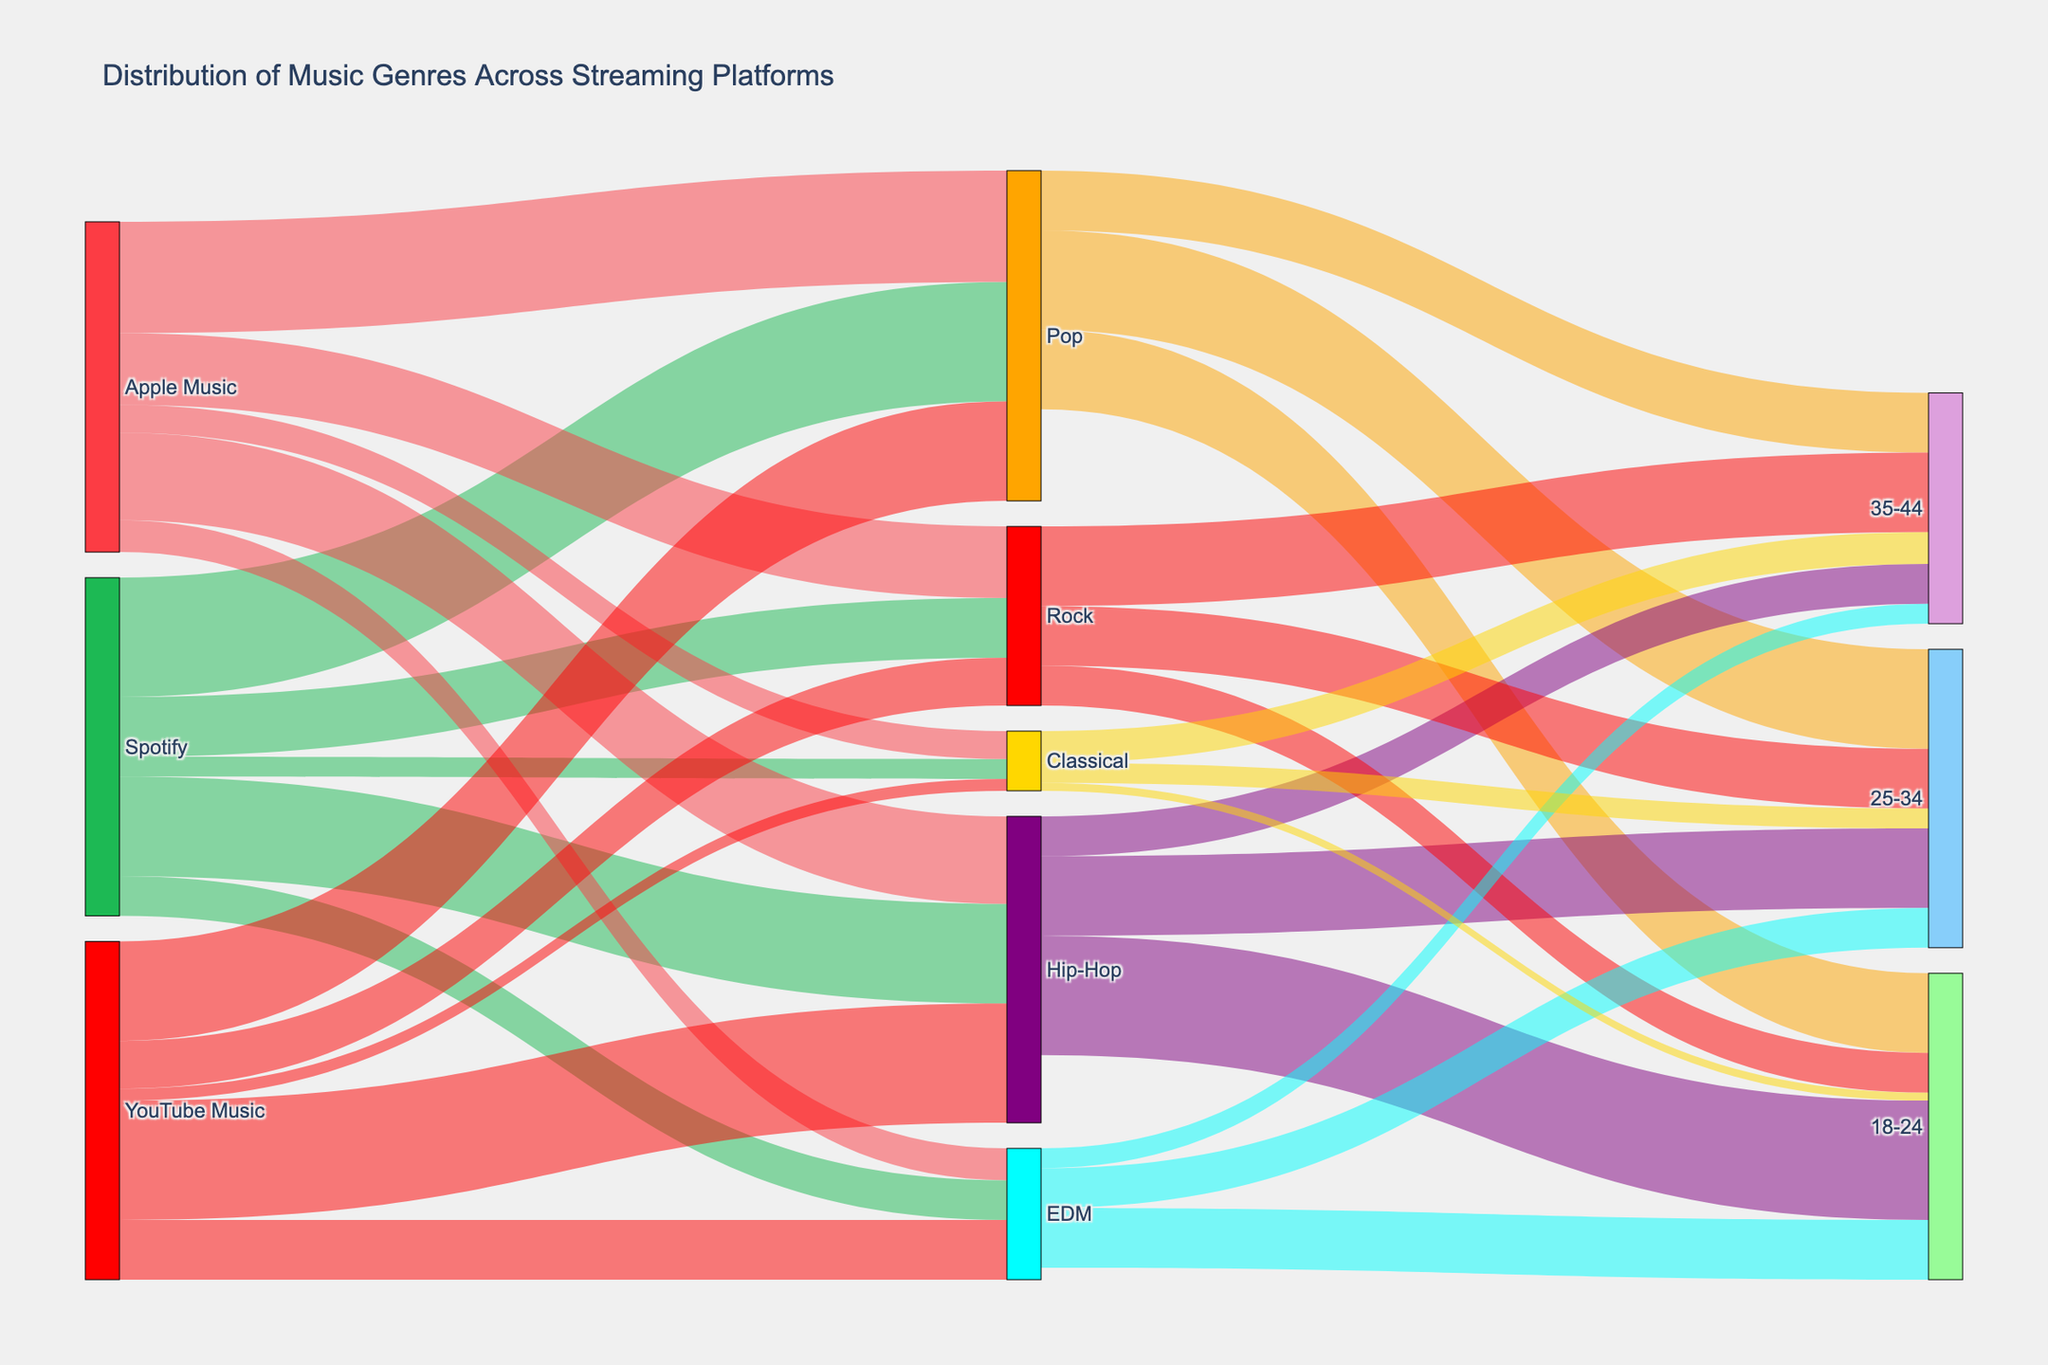What is the most popular music genre on Spotify? According to the Sankey diagram, the highest value link connected to Spotify is directed towards Pop, with a value of 30, making it the most popular genre on the platform.
Answer: Pop Which age group prefers Classical music the least? Based on the links directed towards Classical music, the 18-24 age group has the smallest value of 2, indicating they prefer it the least.
Answer: 18-24 Which platform has the highest proportion of Hip-Hop listeners? The highest value linked to Hip-Hop is from YouTube Music, with a value of 30, compared to values of 25 and 22 for Spotify and Apple Music, respectively.
Answer: YouTube Music How much more popular is Rock on Apple Music than on Spotify? The values linked to Rock are 18 for Apple Music and 15 for Spotify. The difference is calculated as 18 - 15 = 3.
Answer: 3 What is the combined market share of EDM across all platforms? Summing the values for EDM across Spotify (10), Apple Music (8), and YouTube Music (15) gives a combined market share of 10 + 8 + 15 = 33.
Answer: 33 Which genre shows the highest popularity among the 18-24 age group? Hip-Hop has the highest value directed from the 18-24 age group with 30, making it the most popular genre among this age group.
Answer: Hip-Hop What is the difference between the number of Pop listeners on Spotify and Apple Music? The values are 30 for Spotify and 28 for Apple Music. The difference is calculated as 30 - 28 = 2.
Answer: 2 What is the market share ratio of Pop to Rock on YouTube Music? The values are 25 for Pop and 12 for Rock. The ratio is calculated as 25 / 12 ≈ 2.08.
Answer: 2.08 Which genre has nearly equal shares across Spotify and Apple Music? Pop has values of 30 and 28 on Spotify and Apple Music respectively, which are nearly equal.
Answer: Pop How does the share of 35-44 age group listeners differ for Rock and EDM? The values directed to the 35-44 age group are 20 for Rock and 5 for EDM. The difference is calculated as 20 - 5 = 15.
Answer: 15 